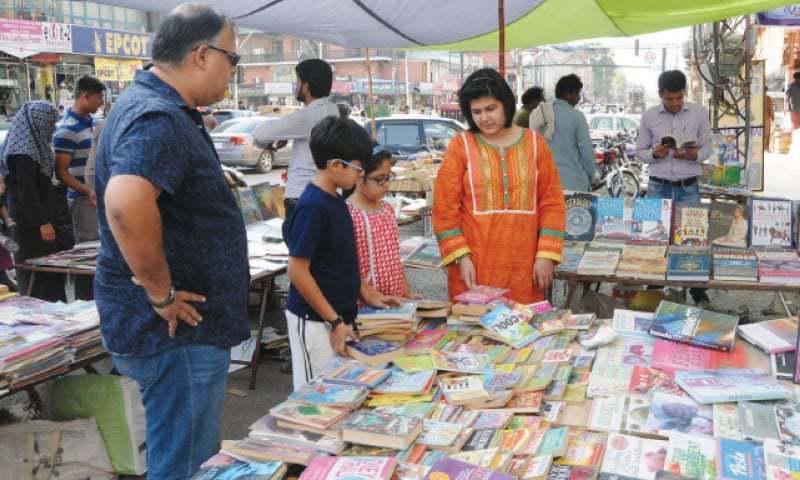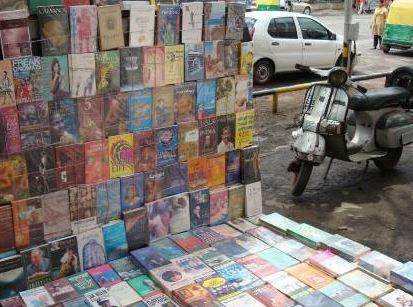The first image is the image on the left, the second image is the image on the right. Evaluate the accuracy of this statement regarding the images: "There are products on the asphalt road in both images.". Is it true? Answer yes or no. Yes. 